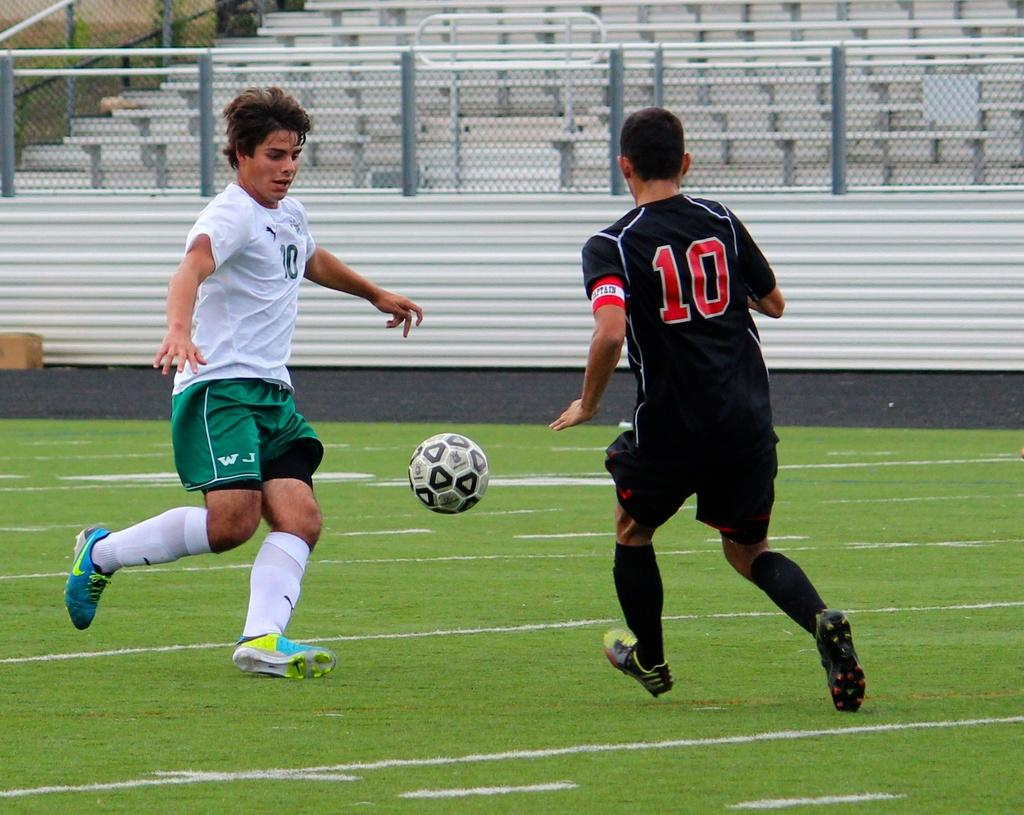<image>
Describe the image concisely. A soccer player in a number 10 shirt faces an opponent from the other team. 